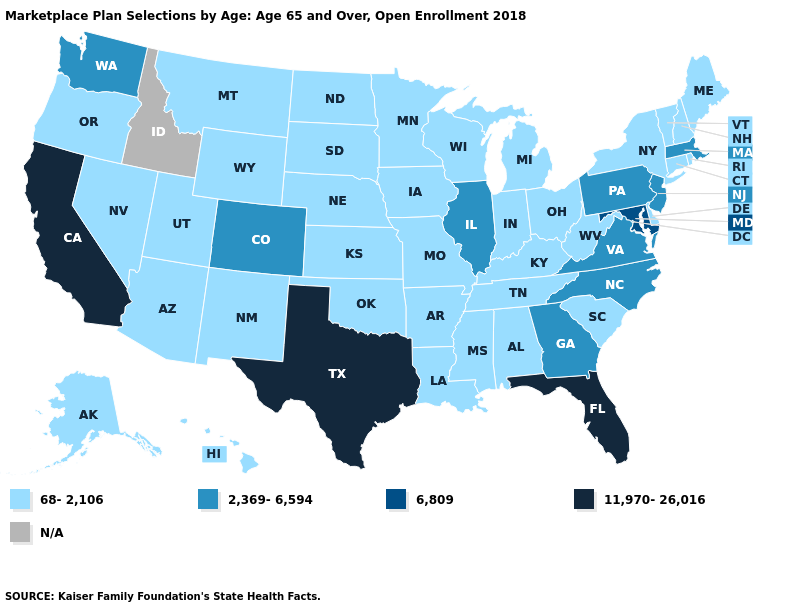Name the states that have a value in the range 11,970-26,016?
Quick response, please. California, Florida, Texas. What is the highest value in the South ?
Concise answer only. 11,970-26,016. Name the states that have a value in the range 2,369-6,594?
Be succinct. Colorado, Georgia, Illinois, Massachusetts, New Jersey, North Carolina, Pennsylvania, Virginia, Washington. What is the value of New Hampshire?
Be succinct. 68-2,106. What is the highest value in the West ?
Short answer required. 11,970-26,016. What is the value of Kansas?
Write a very short answer. 68-2,106. What is the value of Maryland?
Give a very brief answer. 6,809. Does Utah have the highest value in the West?
Answer briefly. No. What is the value of Illinois?
Write a very short answer. 2,369-6,594. How many symbols are there in the legend?
Concise answer only. 5. Which states have the highest value in the USA?
Write a very short answer. California, Florida, Texas. Which states hav the highest value in the MidWest?
Quick response, please. Illinois. Does the first symbol in the legend represent the smallest category?
Quick response, please. Yes. Name the states that have a value in the range 6,809?
Write a very short answer. Maryland. Name the states that have a value in the range 2,369-6,594?
Write a very short answer. Colorado, Georgia, Illinois, Massachusetts, New Jersey, North Carolina, Pennsylvania, Virginia, Washington. 